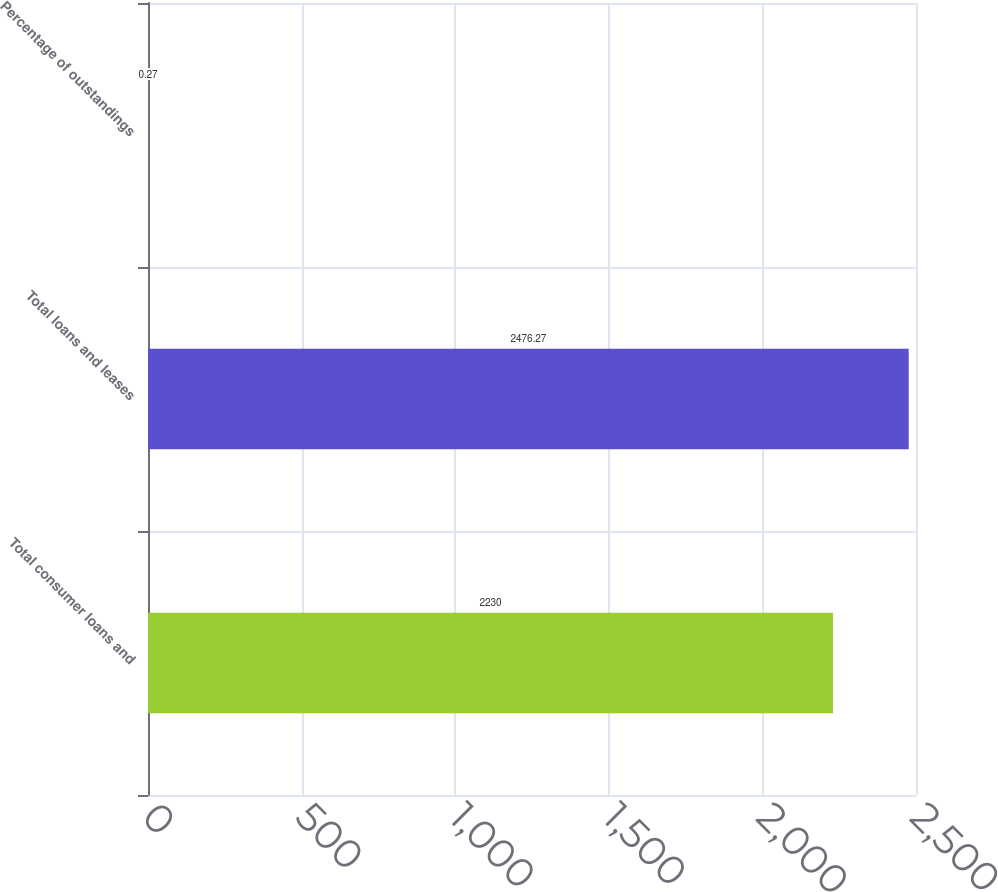<chart> <loc_0><loc_0><loc_500><loc_500><bar_chart><fcel>Total consumer loans and<fcel>Total loans and leases<fcel>Percentage of outstandings<nl><fcel>2230<fcel>2476.27<fcel>0.27<nl></chart> 